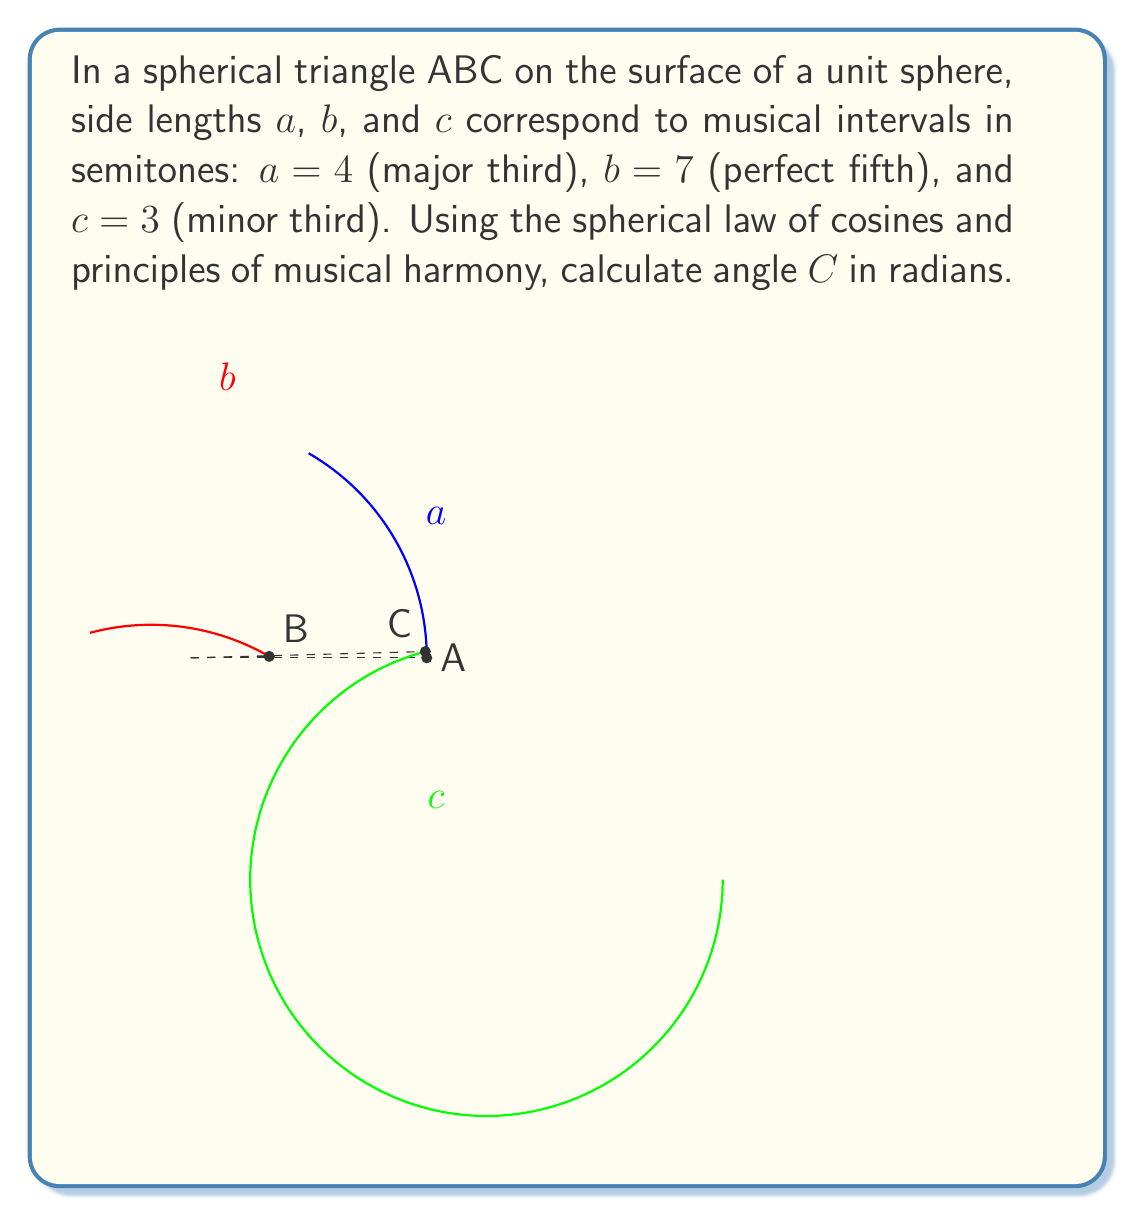Provide a solution to this math problem. Let's approach this step-by-step:

1) In musical theory, intervals are measured in semitones. We're given:
   $a = 4$ semitones (major third)
   $b = 7$ semitones (perfect fifth)
   $c = 3$ semitones (minor third)

2) To use these in spherical trigonometry, we need to convert semitones to radians. There are 12 semitones in an octave, which corresponds to $2\pi$ radians. So, we multiply each by $\frac{\pi}{6}$:

   $a = 4 \cdot \frac{\pi}{6} = \frac{2\pi}{3}$
   $b = 7 \cdot \frac{\pi}{6} = \frac{7\pi}{6}$
   $c = 3 \cdot \frac{\pi}{6} = \frac{\pi}{2}$

3) The spherical law of cosines states:
   $$\cos c = \cos a \cos b + \sin a \sin b \cos C$$

4) Rearranging to solve for $\cos C$:
   $$\cos C = \frac{\cos c - \cos a \cos b}{\sin a \sin b}$$

5) Substituting our values:
   $$\cos C = \frac{\cos(\frac{\pi}{2}) - \cos(\frac{2\pi}{3}) \cos(\frac{7\pi}{6})}{\sin(\frac{2\pi}{3}) \sin(\frac{7\pi}{6})}$$

6) Evaluating:
   $$\cos C = \frac{0 - (-\frac{1}{2}) \cdot (-\frac{\sqrt{3}}{2})}{\frac{\sqrt{3}}{2} \cdot \frac{1}{2}} = \frac{-\frac{\sqrt{3}}{4}}{\frac{\sqrt{3}}{4}} = -1$$

7) Therefore:
   $$C = \arccos(-1) = \pi$$

This result is musically significant as $\pi$ radians corresponds to a tritone (6 semitones), which is half an octave and has been historically important in Western music.
Answer: $\pi$ radians 